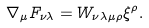Convert formula to latex. <formula><loc_0><loc_0><loc_500><loc_500>\nabla _ { \mu } F _ { \nu \lambda } = W _ { \nu \lambda \mu \rho } \xi ^ { \rho } .</formula> 